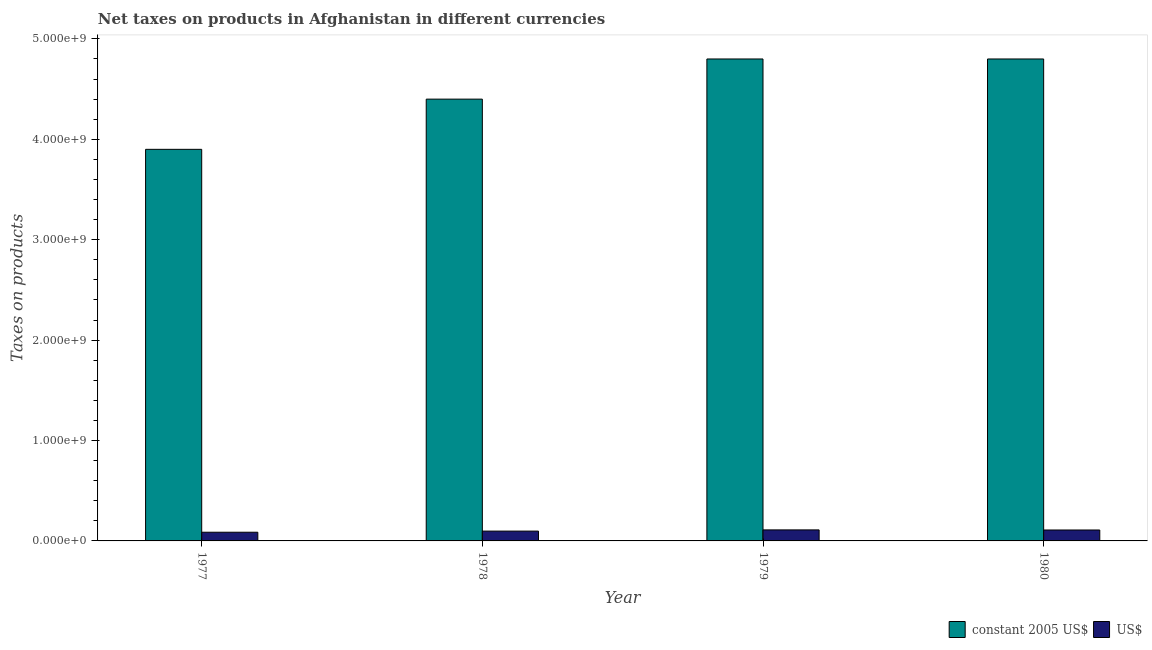Are the number of bars per tick equal to the number of legend labels?
Provide a short and direct response. Yes. Are the number of bars on each tick of the X-axis equal?
Give a very brief answer. Yes. How many bars are there on the 4th tick from the left?
Make the answer very short. 2. How many bars are there on the 3rd tick from the right?
Your answer should be very brief. 2. What is the label of the 4th group of bars from the left?
Keep it short and to the point. 1980. What is the net taxes in constant 2005 us$ in 1977?
Offer a very short reply. 3.90e+09. Across all years, what is the maximum net taxes in constant 2005 us$?
Give a very brief answer. 4.80e+09. Across all years, what is the minimum net taxes in us$?
Provide a short and direct response. 8.67e+07. In which year was the net taxes in us$ maximum?
Offer a terse response. 1979. What is the total net taxes in constant 2005 us$ in the graph?
Your answer should be very brief. 1.79e+1. What is the difference between the net taxes in constant 2005 us$ in 1978 and that in 1979?
Keep it short and to the point. -4.00e+08. What is the difference between the net taxes in us$ in 1978 and the net taxes in constant 2005 us$ in 1979?
Keep it short and to the point. -1.21e+07. What is the average net taxes in us$ per year?
Offer a very short reply. 1.01e+08. In how many years, is the net taxes in us$ greater than 600000000 units?
Offer a terse response. 0. What is the ratio of the net taxes in constant 2005 us$ in 1977 to that in 1979?
Provide a succinct answer. 0.81. Is the net taxes in us$ in 1978 less than that in 1979?
Ensure brevity in your answer.  Yes. What is the difference between the highest and the lowest net taxes in constant 2005 us$?
Provide a short and direct response. 9.00e+08. Is the sum of the net taxes in us$ in 1977 and 1978 greater than the maximum net taxes in constant 2005 us$ across all years?
Keep it short and to the point. Yes. What does the 2nd bar from the left in 1980 represents?
Keep it short and to the point. US$. What does the 1st bar from the right in 1979 represents?
Make the answer very short. US$. How many bars are there?
Provide a succinct answer. 8. Are all the bars in the graph horizontal?
Provide a succinct answer. No. What is the difference between two consecutive major ticks on the Y-axis?
Your answer should be compact. 1.00e+09. Are the values on the major ticks of Y-axis written in scientific E-notation?
Give a very brief answer. Yes. Where does the legend appear in the graph?
Keep it short and to the point. Bottom right. What is the title of the graph?
Provide a succinct answer. Net taxes on products in Afghanistan in different currencies. Does "Net National savings" appear as one of the legend labels in the graph?
Your answer should be very brief. No. What is the label or title of the X-axis?
Offer a very short reply. Year. What is the label or title of the Y-axis?
Your answer should be compact. Taxes on products. What is the Taxes on products in constant 2005 US$ in 1977?
Offer a terse response. 3.90e+09. What is the Taxes on products in US$ in 1977?
Provide a short and direct response. 8.67e+07. What is the Taxes on products in constant 2005 US$ in 1978?
Your answer should be compact. 4.40e+09. What is the Taxes on products of US$ in 1978?
Provide a short and direct response. 9.78e+07. What is the Taxes on products in constant 2005 US$ in 1979?
Provide a succinct answer. 4.80e+09. What is the Taxes on products of US$ in 1979?
Give a very brief answer. 1.10e+08. What is the Taxes on products of constant 2005 US$ in 1980?
Offer a terse response. 4.80e+09. What is the Taxes on products in US$ in 1980?
Keep it short and to the point. 1.09e+08. Across all years, what is the maximum Taxes on products in constant 2005 US$?
Make the answer very short. 4.80e+09. Across all years, what is the maximum Taxes on products of US$?
Your answer should be compact. 1.10e+08. Across all years, what is the minimum Taxes on products in constant 2005 US$?
Give a very brief answer. 3.90e+09. Across all years, what is the minimum Taxes on products of US$?
Provide a succinct answer. 8.67e+07. What is the total Taxes on products of constant 2005 US$ in the graph?
Ensure brevity in your answer.  1.79e+1. What is the total Taxes on products of US$ in the graph?
Provide a short and direct response. 4.03e+08. What is the difference between the Taxes on products of constant 2005 US$ in 1977 and that in 1978?
Keep it short and to the point. -5.00e+08. What is the difference between the Taxes on products in US$ in 1977 and that in 1978?
Your answer should be compact. -1.11e+07. What is the difference between the Taxes on products of constant 2005 US$ in 1977 and that in 1979?
Offer a very short reply. -9.00e+08. What is the difference between the Taxes on products of US$ in 1977 and that in 1979?
Your answer should be very brief. -2.32e+07. What is the difference between the Taxes on products in constant 2005 US$ in 1977 and that in 1980?
Keep it short and to the point. -9.00e+08. What is the difference between the Taxes on products of US$ in 1977 and that in 1980?
Your response must be concise. -2.22e+07. What is the difference between the Taxes on products in constant 2005 US$ in 1978 and that in 1979?
Offer a very short reply. -4.00e+08. What is the difference between the Taxes on products of US$ in 1978 and that in 1979?
Your response must be concise. -1.21e+07. What is the difference between the Taxes on products of constant 2005 US$ in 1978 and that in 1980?
Provide a succinct answer. -4.00e+08. What is the difference between the Taxes on products in US$ in 1978 and that in 1980?
Provide a short and direct response. -1.11e+07. What is the difference between the Taxes on products of US$ in 1979 and that in 1980?
Offer a terse response. 9.96e+05. What is the difference between the Taxes on products in constant 2005 US$ in 1977 and the Taxes on products in US$ in 1978?
Provide a succinct answer. 3.80e+09. What is the difference between the Taxes on products in constant 2005 US$ in 1977 and the Taxes on products in US$ in 1979?
Give a very brief answer. 3.79e+09. What is the difference between the Taxes on products in constant 2005 US$ in 1977 and the Taxes on products in US$ in 1980?
Your answer should be very brief. 3.79e+09. What is the difference between the Taxes on products in constant 2005 US$ in 1978 and the Taxes on products in US$ in 1979?
Your answer should be compact. 4.29e+09. What is the difference between the Taxes on products in constant 2005 US$ in 1978 and the Taxes on products in US$ in 1980?
Give a very brief answer. 4.29e+09. What is the difference between the Taxes on products of constant 2005 US$ in 1979 and the Taxes on products of US$ in 1980?
Your response must be concise. 4.69e+09. What is the average Taxes on products in constant 2005 US$ per year?
Your answer should be very brief. 4.48e+09. What is the average Taxes on products of US$ per year?
Offer a very short reply. 1.01e+08. In the year 1977, what is the difference between the Taxes on products in constant 2005 US$ and Taxes on products in US$?
Keep it short and to the point. 3.81e+09. In the year 1978, what is the difference between the Taxes on products in constant 2005 US$ and Taxes on products in US$?
Provide a short and direct response. 4.30e+09. In the year 1979, what is the difference between the Taxes on products of constant 2005 US$ and Taxes on products of US$?
Keep it short and to the point. 4.69e+09. In the year 1980, what is the difference between the Taxes on products in constant 2005 US$ and Taxes on products in US$?
Keep it short and to the point. 4.69e+09. What is the ratio of the Taxes on products of constant 2005 US$ in 1977 to that in 1978?
Offer a terse response. 0.89. What is the ratio of the Taxes on products of US$ in 1977 to that in 1978?
Your answer should be compact. 0.89. What is the ratio of the Taxes on products of constant 2005 US$ in 1977 to that in 1979?
Your response must be concise. 0.81. What is the ratio of the Taxes on products of US$ in 1977 to that in 1979?
Provide a succinct answer. 0.79. What is the ratio of the Taxes on products of constant 2005 US$ in 1977 to that in 1980?
Keep it short and to the point. 0.81. What is the ratio of the Taxes on products of US$ in 1977 to that in 1980?
Your response must be concise. 0.8. What is the ratio of the Taxes on products in US$ in 1978 to that in 1979?
Provide a short and direct response. 0.89. What is the ratio of the Taxes on products in US$ in 1978 to that in 1980?
Keep it short and to the point. 0.9. What is the ratio of the Taxes on products in US$ in 1979 to that in 1980?
Provide a short and direct response. 1.01. What is the difference between the highest and the second highest Taxes on products in US$?
Your answer should be compact. 9.96e+05. What is the difference between the highest and the lowest Taxes on products in constant 2005 US$?
Your answer should be compact. 9.00e+08. What is the difference between the highest and the lowest Taxes on products of US$?
Offer a terse response. 2.32e+07. 